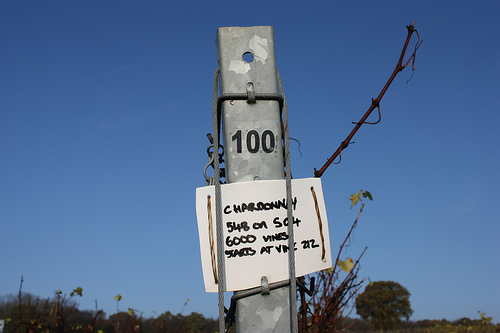<image>
Is the sky behind the electric tower? Yes. From this viewpoint, the sky is positioned behind the electric tower, with the electric tower partially or fully occluding the sky. 